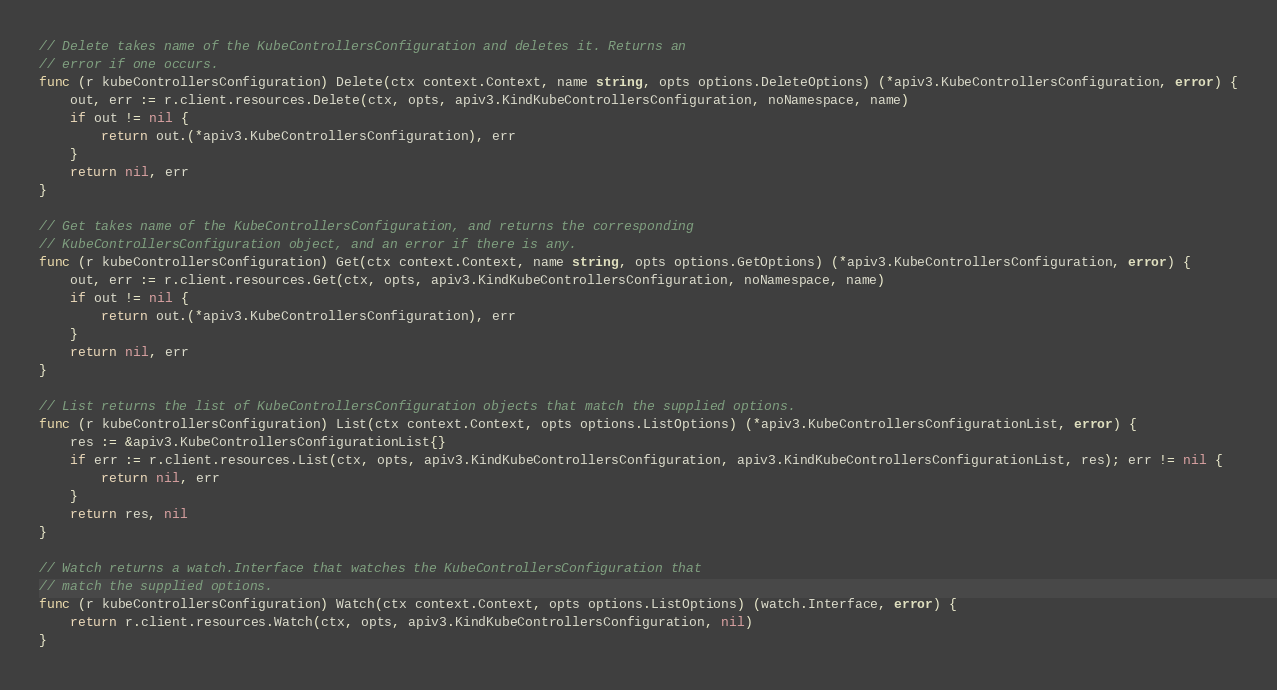<code> <loc_0><loc_0><loc_500><loc_500><_Go_>
// Delete takes name of the KubeControllersConfiguration and deletes it. Returns an
// error if one occurs.
func (r kubeControllersConfiguration) Delete(ctx context.Context, name string, opts options.DeleteOptions) (*apiv3.KubeControllersConfiguration, error) {
	out, err := r.client.resources.Delete(ctx, opts, apiv3.KindKubeControllersConfiguration, noNamespace, name)
	if out != nil {
		return out.(*apiv3.KubeControllersConfiguration), err
	}
	return nil, err
}

// Get takes name of the KubeControllersConfiguration, and returns the corresponding
// KubeControllersConfiguration object, and an error if there is any.
func (r kubeControllersConfiguration) Get(ctx context.Context, name string, opts options.GetOptions) (*apiv3.KubeControllersConfiguration, error) {
	out, err := r.client.resources.Get(ctx, opts, apiv3.KindKubeControllersConfiguration, noNamespace, name)
	if out != nil {
		return out.(*apiv3.KubeControllersConfiguration), err
	}
	return nil, err
}

// List returns the list of KubeControllersConfiguration objects that match the supplied options.
func (r kubeControllersConfiguration) List(ctx context.Context, opts options.ListOptions) (*apiv3.KubeControllersConfigurationList, error) {
	res := &apiv3.KubeControllersConfigurationList{}
	if err := r.client.resources.List(ctx, opts, apiv3.KindKubeControllersConfiguration, apiv3.KindKubeControllersConfigurationList, res); err != nil {
		return nil, err
	}
	return res, nil
}

// Watch returns a watch.Interface that watches the KubeControllersConfiguration that
// match the supplied options.
func (r kubeControllersConfiguration) Watch(ctx context.Context, opts options.ListOptions) (watch.Interface, error) {
	return r.client.resources.Watch(ctx, opts, apiv3.KindKubeControllersConfiguration, nil)
}
</code> 